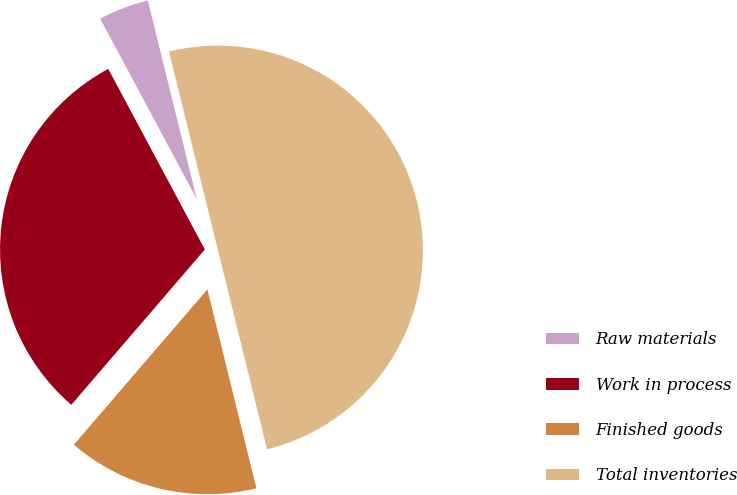Convert chart to OTSL. <chart><loc_0><loc_0><loc_500><loc_500><pie_chart><fcel>Raw materials<fcel>Work in process<fcel>Finished goods<fcel>Total inventories<nl><fcel>3.97%<fcel>30.88%<fcel>15.15%<fcel>50.0%<nl></chart> 